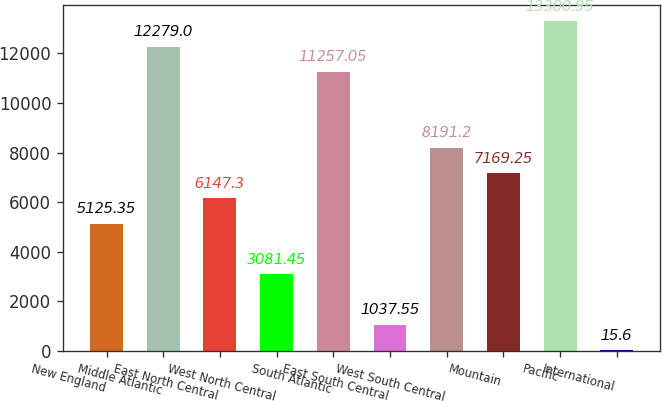Convert chart to OTSL. <chart><loc_0><loc_0><loc_500><loc_500><bar_chart><fcel>New England<fcel>Middle Atlantic<fcel>East North Central<fcel>West North Central<fcel>South Atlantic<fcel>East South Central<fcel>West South Central<fcel>Mountain<fcel>Pacific<fcel>International<nl><fcel>5125.35<fcel>12279<fcel>6147.3<fcel>3081.45<fcel>11257<fcel>1037.55<fcel>8191.2<fcel>7169.25<fcel>13301<fcel>15.6<nl></chart> 